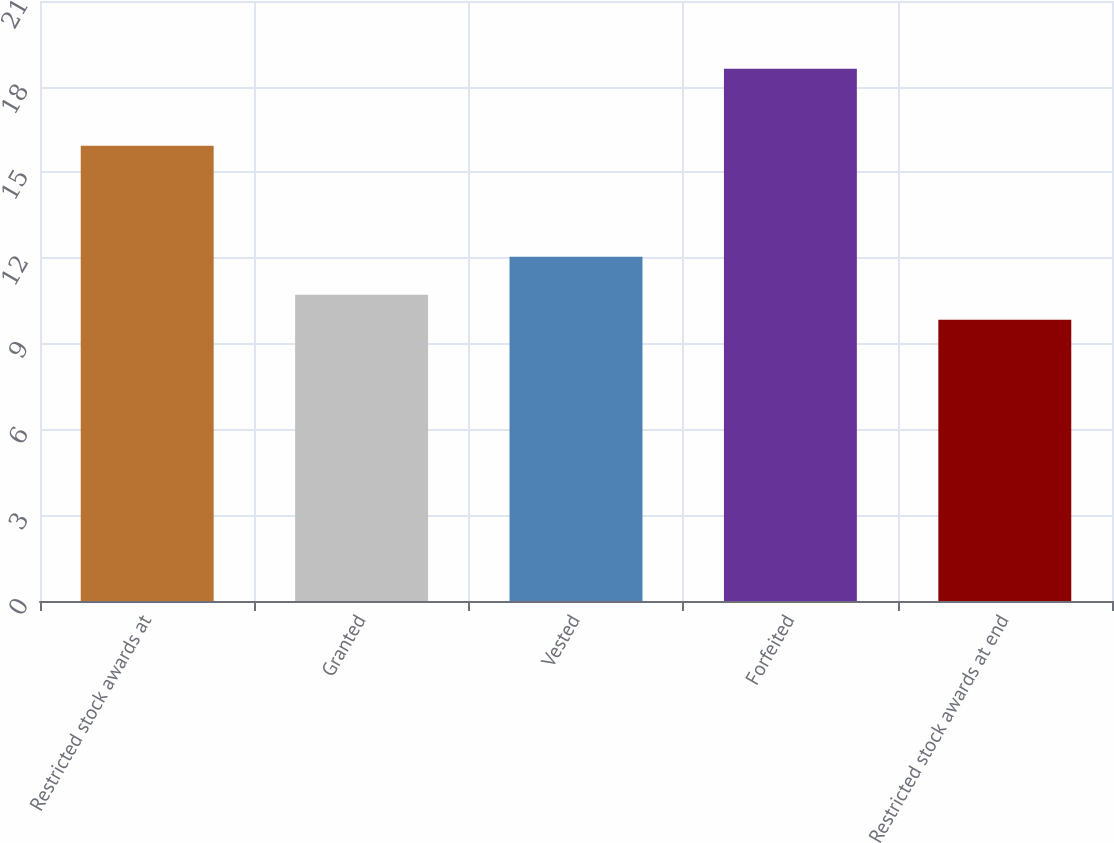Convert chart to OTSL. <chart><loc_0><loc_0><loc_500><loc_500><bar_chart><fcel>Restricted stock awards at<fcel>Granted<fcel>Vested<fcel>Forfeited<fcel>Restricted stock awards at end<nl><fcel>15.93<fcel>10.72<fcel>12.05<fcel>18.63<fcel>9.84<nl></chart> 